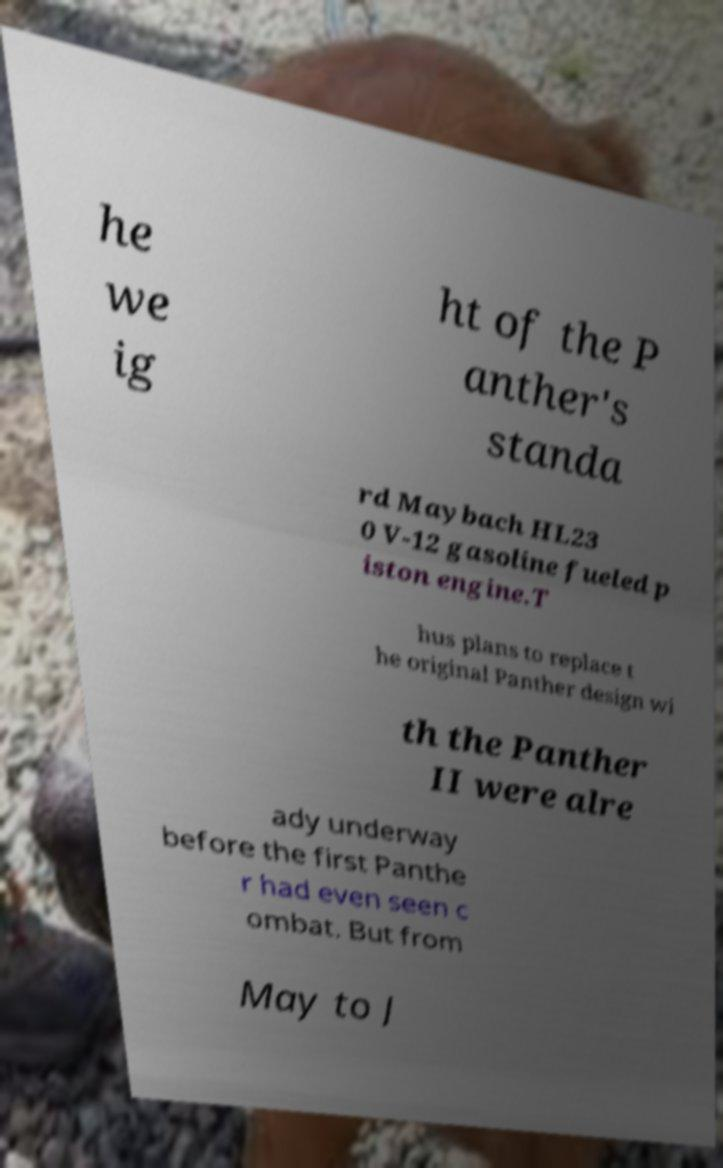Can you accurately transcribe the text from the provided image for me? he we ig ht of the P anther's standa rd Maybach HL23 0 V-12 gasoline fueled p iston engine.T hus plans to replace t he original Panther design wi th the Panther II were alre ady underway before the first Panthe r had even seen c ombat. But from May to J 